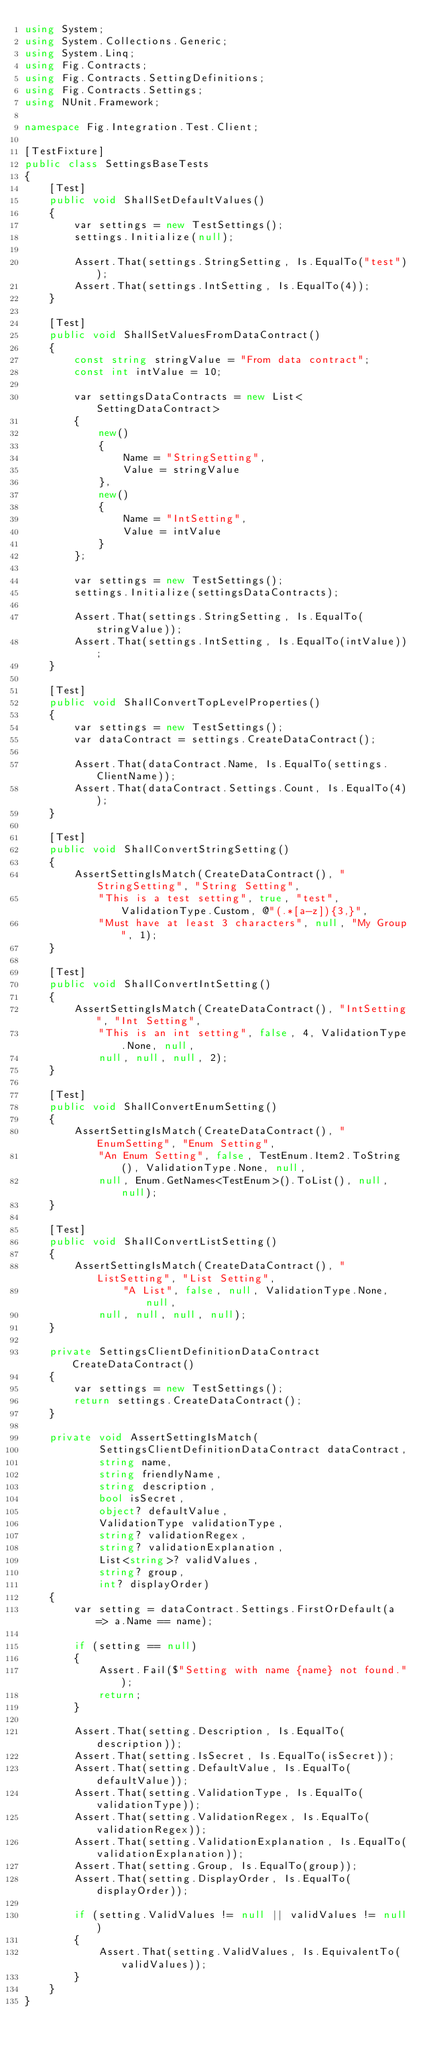<code> <loc_0><loc_0><loc_500><loc_500><_C#_>using System;
using System.Collections.Generic;
using System.Linq;
using Fig.Contracts;
using Fig.Contracts.SettingDefinitions;
using Fig.Contracts.Settings;
using NUnit.Framework;

namespace Fig.Integration.Test.Client;

[TestFixture]
public class SettingsBaseTests
{
    [Test]
    public void ShallSetDefaultValues()
    {
        var settings = new TestSettings();
        settings.Initialize(null);

        Assert.That(settings.StringSetting, Is.EqualTo("test"));
        Assert.That(settings.IntSetting, Is.EqualTo(4));
    }

    [Test]
    public void ShallSetValuesFromDataContract()
    {
        const string stringValue = "From data contract";
        const int intValue = 10;

        var settingsDataContracts = new List<SettingDataContract>
        {
            new()
            {
                Name = "StringSetting",
                Value = stringValue
            },
            new()
            {
                Name = "IntSetting",
                Value = intValue
            }
        };

        var settings = new TestSettings();
        settings.Initialize(settingsDataContracts);

        Assert.That(settings.StringSetting, Is.EqualTo(stringValue));
        Assert.That(settings.IntSetting, Is.EqualTo(intValue));
    }

    [Test]
    public void ShallConvertTopLevelProperties()
    {
        var settings = new TestSettings();
        var dataContract = settings.CreateDataContract();

        Assert.That(dataContract.Name, Is.EqualTo(settings.ClientName));
        Assert.That(dataContract.Settings.Count, Is.EqualTo(4));
    }

    [Test]
    public void ShallConvertStringSetting()
    {
        AssertSettingIsMatch(CreateDataContract(), "StringSetting", "String Setting",
            "This is a test setting", true, "test", ValidationType.Custom, @"(.*[a-z]){3,}",
            "Must have at least 3 characters", null, "My Group", 1);
    }

    [Test]
    public void ShallConvertIntSetting()
    {
        AssertSettingIsMatch(CreateDataContract(), "IntSetting", "Int Setting",
            "This is an int setting", false, 4, ValidationType.None, null,
            null, null, null, 2);
    }

    [Test]
    public void ShallConvertEnumSetting()
    {
        AssertSettingIsMatch(CreateDataContract(), "EnumSetting", "Enum Setting",
            "An Enum Setting", false, TestEnum.Item2.ToString(), ValidationType.None, null,
            null, Enum.GetNames<TestEnum>().ToList(), null, null);
    }

    [Test]
    public void ShallConvertListSetting()
    {
        AssertSettingIsMatch(CreateDataContract(), "ListSetting", "List Setting",
                "A List", false, null, ValidationType.None, null,
            null, null, null, null);
    }

    private SettingsClientDefinitionDataContract CreateDataContract()
    {
        var settings = new TestSettings();
        return settings.CreateDataContract();
    }

    private void AssertSettingIsMatch(
            SettingsClientDefinitionDataContract dataContract,
            string name,
            string friendlyName,
            string description,
            bool isSecret,
            object? defaultValue,
            ValidationType validationType,
            string? validationRegex,
            string? validationExplanation,
            List<string>? validValues,
            string? group,
            int? displayOrder)
    {
        var setting = dataContract.Settings.FirstOrDefault(a => a.Name == name);

        if (setting == null)
        {
            Assert.Fail($"Setting with name {name} not found.");
            return;
        }

        Assert.That(setting.Description, Is.EqualTo(description));
        Assert.That(setting.IsSecret, Is.EqualTo(isSecret));
        Assert.That(setting.DefaultValue, Is.EqualTo(defaultValue));
        Assert.That(setting.ValidationType, Is.EqualTo(validationType));
        Assert.That(setting.ValidationRegex, Is.EqualTo(validationRegex));
        Assert.That(setting.ValidationExplanation, Is.EqualTo(validationExplanation));
        Assert.That(setting.Group, Is.EqualTo(group));
        Assert.That(setting.DisplayOrder, Is.EqualTo(displayOrder));

        if (setting.ValidValues != null || validValues != null)
        {
            Assert.That(setting.ValidValues, Is.EquivalentTo(validValues));
        }
    }
}</code> 